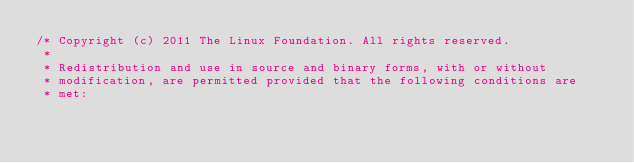<code> <loc_0><loc_0><loc_500><loc_500><_C_>/* Copyright (c) 2011 The Linux Foundation. All rights reserved.
 *
 * Redistribution and use in source and binary forms, with or without
 * modification, are permitted provided that the following conditions are
 * met:</code> 